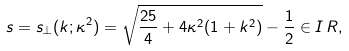<formula> <loc_0><loc_0><loc_500><loc_500>s = s _ { \perp } ( k ; \kappa ^ { 2 } ) = \sqrt { \frac { 2 5 } { 4 } + 4 \kappa ^ { 2 } ( 1 + k ^ { 2 } ) } - \frac { 1 } { 2 } \in I \, R ,</formula> 